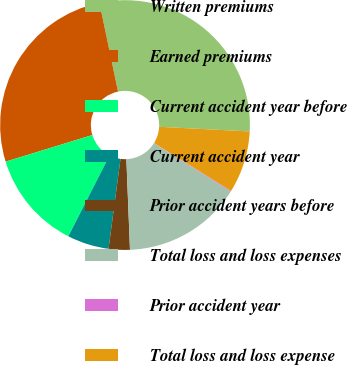<chart> <loc_0><loc_0><loc_500><loc_500><pie_chart><fcel>Written premiums<fcel>Earned premiums<fcel>Current accident year before<fcel>Current accident year<fcel>Prior accident years before<fcel>Total loss and loss expenses<fcel>Prior accident year<fcel>Total loss and loss expense<nl><fcel>29.1%<fcel>26.45%<fcel>12.77%<fcel>5.39%<fcel>2.74%<fcel>15.42%<fcel>0.1%<fcel>8.03%<nl></chart> 